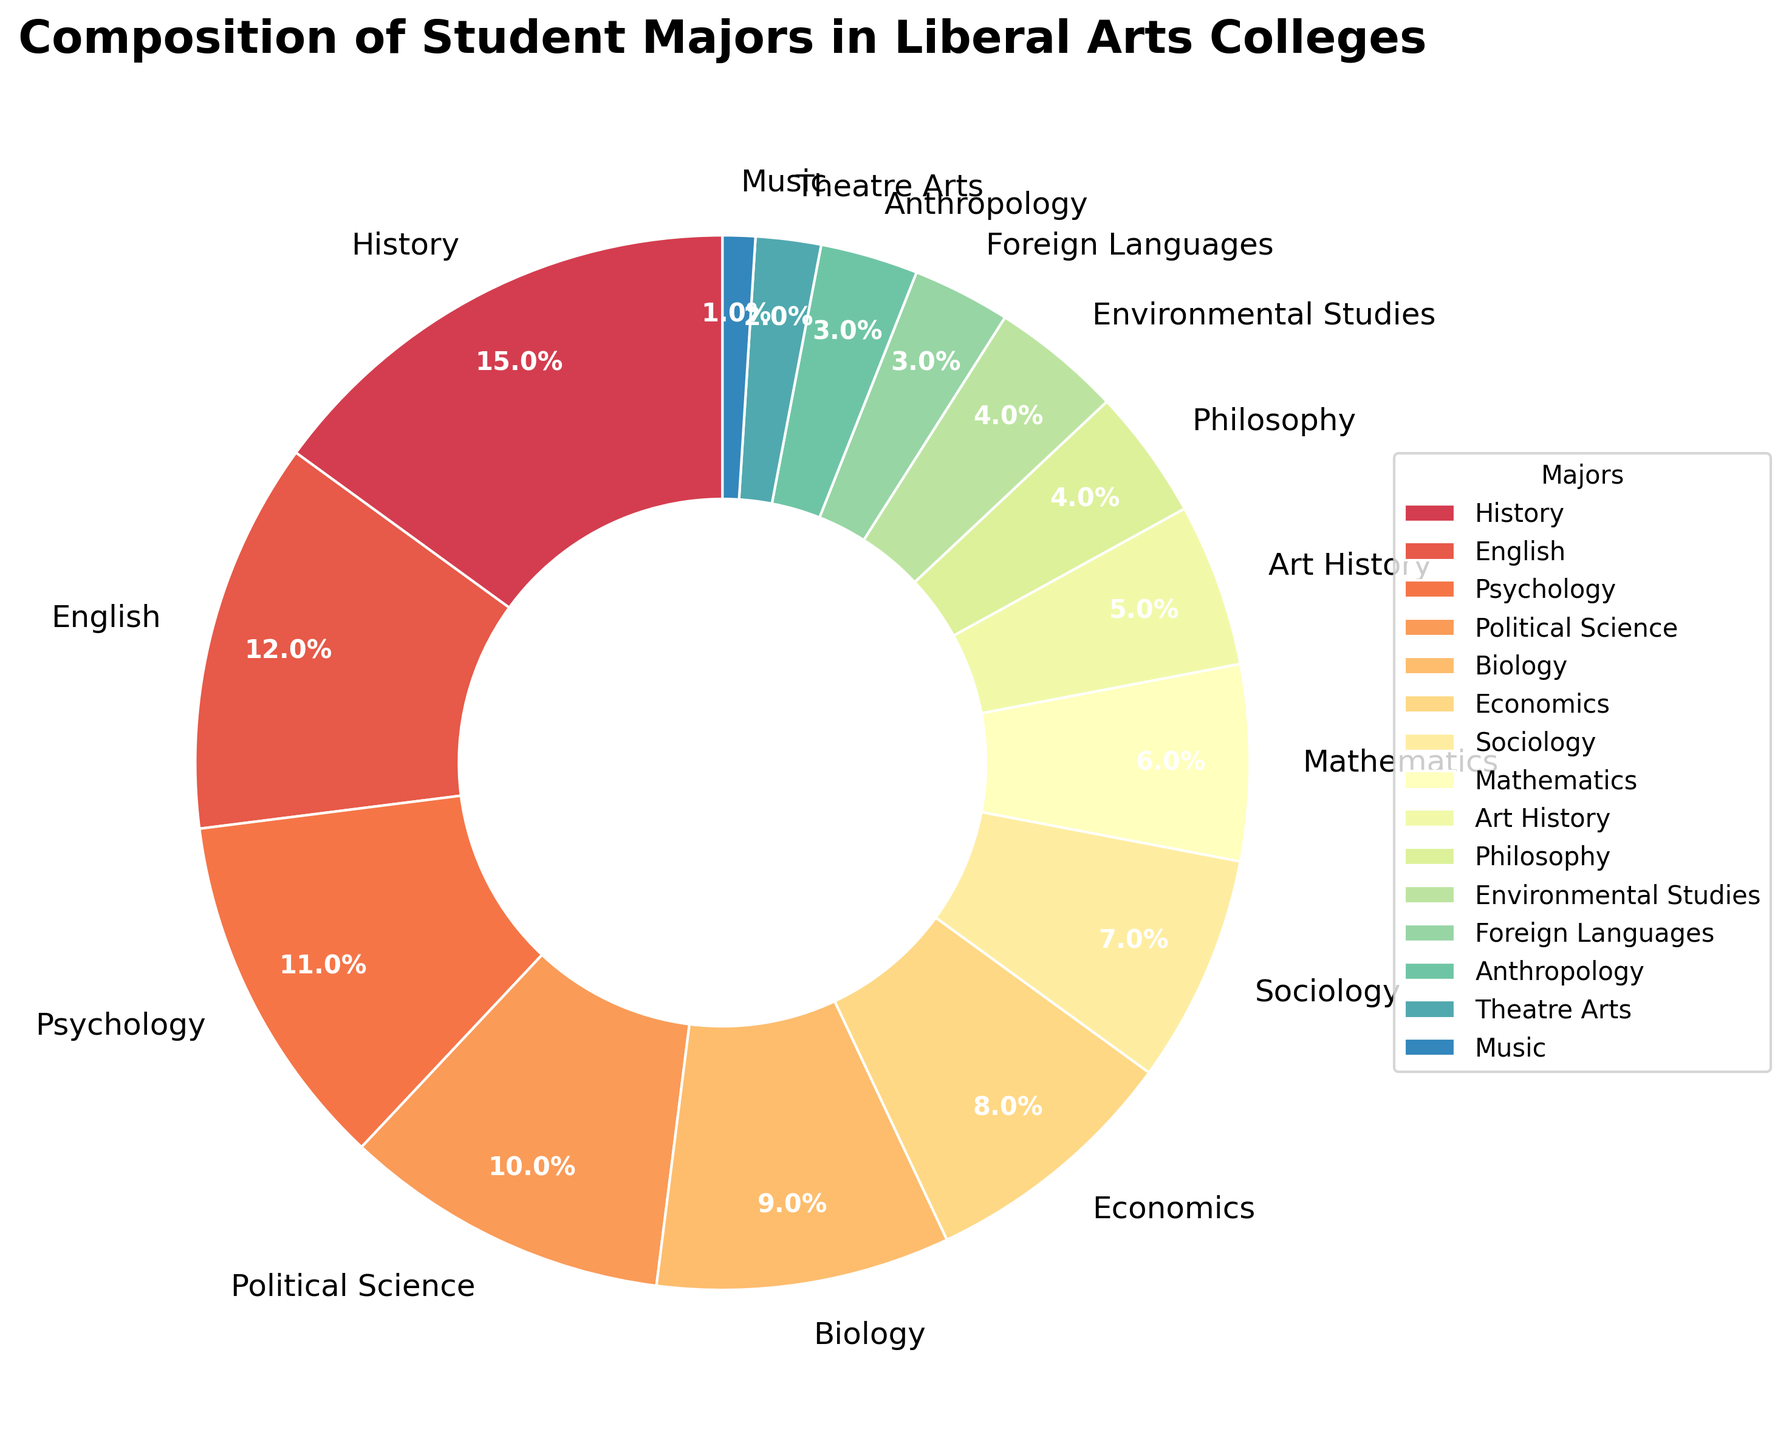What major constitutes the largest percentage of student majors? The pie chart shows the percentages of various student majors, and the largest wedge represents the major with the highest percentage. By looking at the chart, "History" has the largest percentage.
Answer: History Which major constitutes the smallest percentage of student majors? The smallest wedge in the pie chart corresponds to the major with the lowest percentage. "Music" has the smallest percentage in the pie chart.
Answer: Music What is the combined percentage of students majoring in English, Psychology, and Political Science? To find the combined percentage, add the percentages of English (12), Psychology (11), and Political Science (10). The total is \(12 + 11 + 10 = 33\%\).
Answer: 33% Compare the percentage of students majoring in Sociology to those majoring in Art History. Which is higher, and by how much? By referring to the pie chart, Sociology has 7%, and Art History has 5%. To find the difference, subtract 5 from 7, so Sociology is higher by \(7 - 5 = 2\%\).
Answer: Sociology by 2% What's the median percentage value of student majors? To find the median, list the percentages in ascending order: 1, 2, 3, 3, 4, 4, 5, 6, 7, 8, 9, 10, 11, 12, 15. The middle value is the 8th value in this ordered list, which is 6.
Answer: 6 Do more students major in Biology and Economics combined than in History? The combined percentage of Biology (9) and Economics (8) is \(9 + 8 = 17\%\). History alone is 15%. Since 17% is greater than 15%, more students major in Biology and Economics combined than in History.
Answer: Yes Which are the three most popular majors based on the chart? The three largest wedges indicate the three most popular majors. These are History (15%), English (12%), and Psychology (11%).
Answer: History, English, Psychology Are the percentages of students majoring in Environmental Studies and Philosophy equal? According to the pie chart, Environmental Studies and Philosophy both have a percentage of 4%. Since they are equal, the answer is yes.
Answer: Yes How does the percentage of Sociology majors compare to that of Mathematics majors? From the pie chart, Sociology has 7% and Mathematics has 6%. Sociology has a higher percentage than Mathematics by \(7 - 6 = 1\%\).
Answer: Sociology by 1% What's the cumulative percentage of students in the least popular four majors? The least popular majors have the smallest wedges. These are Music (1%), Theatre Arts (2%), Anthropology (3%), and Foreign Languages (3%). Summing these gives \(1 + 2 + 3 + 3 = 9\%\).
Answer: 9% 